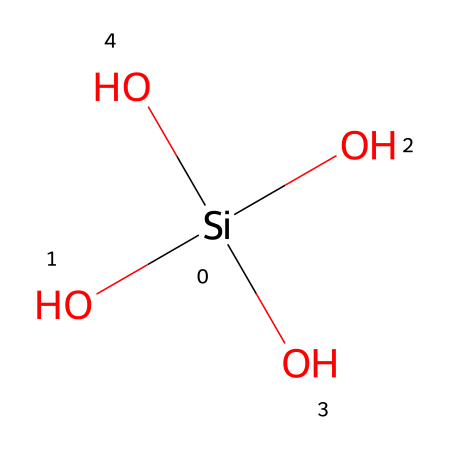How many oxygen atoms are present in this chemical structure? The chemical structure has four oxygen atoms attached to the silicon atom, as indicated by the four 'O' symbols directly bonded to '[Si]'.
Answer: four What is the central atom in this chemical structure? The structure has silicon as the central atom, which is indicated by the '[Si]' notation.
Answer: silicon How many total atoms are present in this molecule? By counting the silicon and the oxygen atoms together, there is one silicon atom and four oxygen atoms, making a total of five atoms.
Answer: five What property of silica contributes to its use in ceramic cooking vessels? The strong bonds between silicon and oxygen provide high thermal stability, which is essential for cooking applications.
Answer: high thermal stability What type of bonding is primarily present in this chemical structure? The structure mainly features covalent bonding between the silicon atom and the oxygen atoms, as represented by the connections shown in the SMILES notation.
Answer: covalent bonding How does the number of hydroxyl groups influence the properties of the ceramic? The presence of multiple hydroxyl groups (indicated by 'O' connected in the hydroxyl fashion) enhances the ceramic's ability to retain moisture, which can affect cooking.
Answer: moisture retention What role does silica play in the durability of ceramic cookware? Silica contributes to the mechanical strength and heat resistance of ceramic cookware, making it less prone to cracking or breaking under heat.
Answer: mechanical strength 